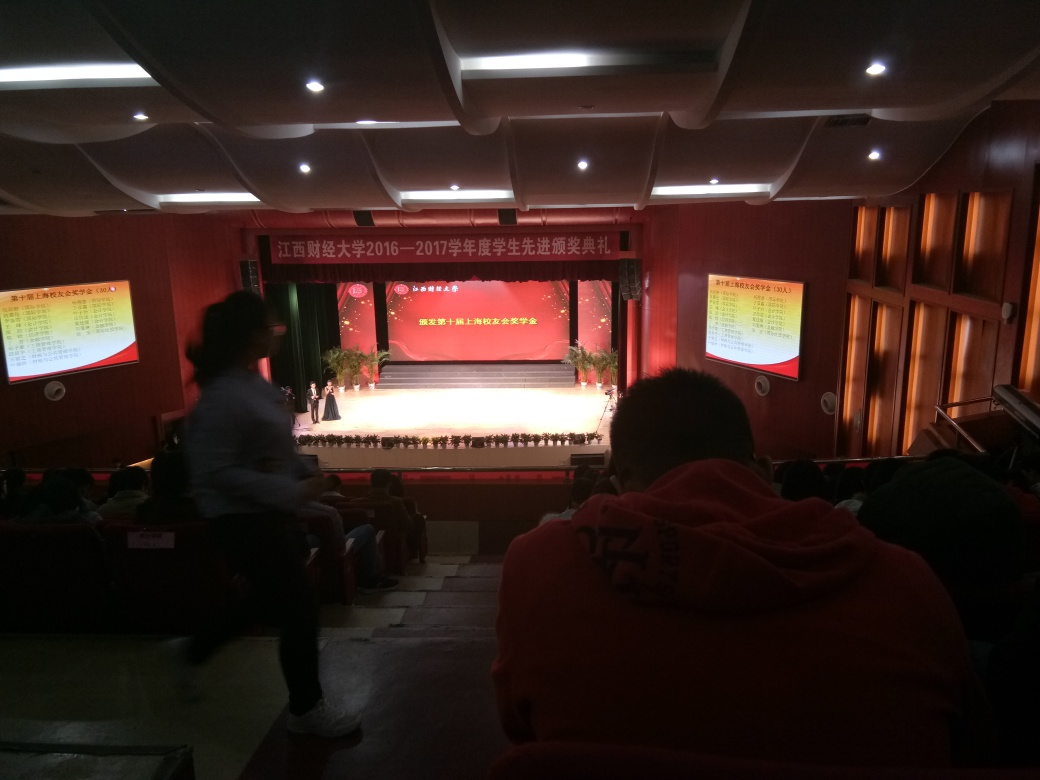Can you describe the atmosphere or mood of the setting in this image? The atmosphere appears focused and formal, fitting for an auditorium setting where an event, possibly an award ceremony or a similar formal gathering, is taking place. The attendees seem to be seated and attentive, waiting for the proceedings on the stage. 